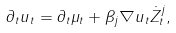<formula> <loc_0><loc_0><loc_500><loc_500>\partial _ { t } u _ { t } = \partial _ { t } \mu _ { t } + \beta _ { j } \nabla u _ { t } \dot { Z } _ { t } ^ { j } ,</formula> 